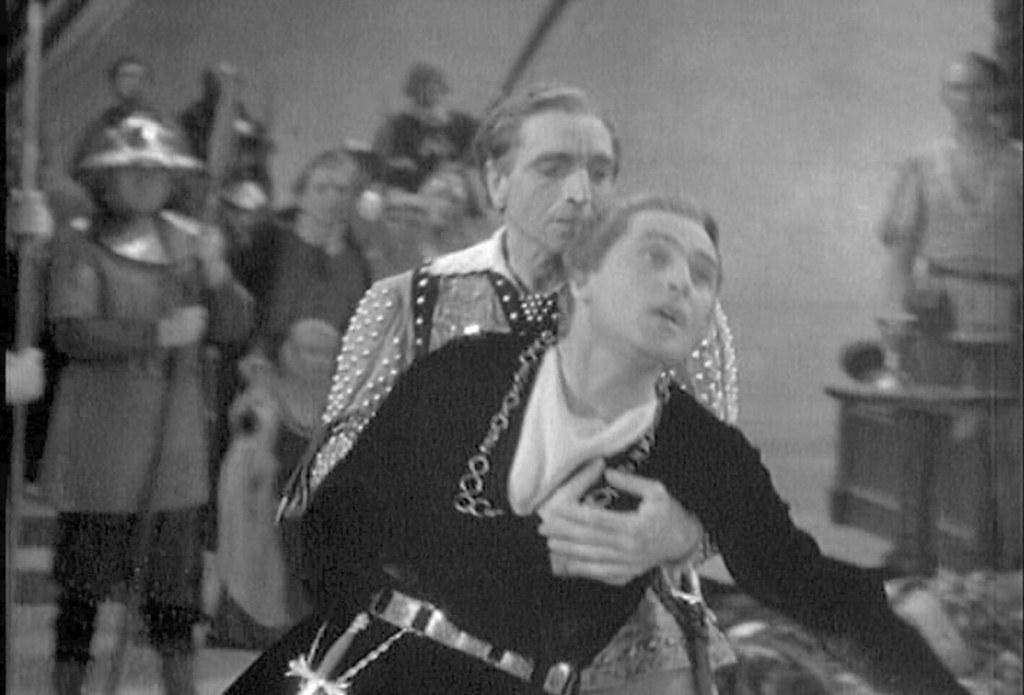Describe this image in one or two sentences. This is an old photograph, in front of the image a person is holding another person from falling, behind them there are a few other people standing by holding sticks in their hands. 